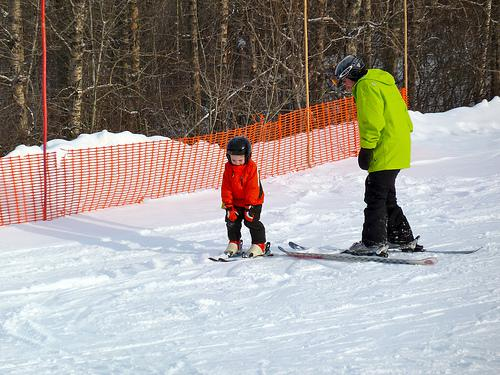Question: where was the picture taken?
Choices:
A. On the beach.
B. On a balcony.
C. In the park.
D. Slopes.
Answer with the letter. Answer: D Question: why is the person wearing goggles?
Choices:
A. To see underwater.
B. To keep snow of their face.
C. Safety.
D. To keep the sun out of their eyes.
Answer with the letter. Answer: C Question: how many people are pictured?
Choices:
A. 1.
B. 2.
C. 3.
D. 4.
Answer with the letter. Answer: B Question: what are the people doing?
Choices:
A. Skiing.
B. Swimming.
C. Laughing.
D. Eating.
Answer with the letter. Answer: A Question: what color is the child's jacket?
Choices:
A. Blue.
B. Black.
C. Red.
D. White.
Answer with the letter. Answer: C 